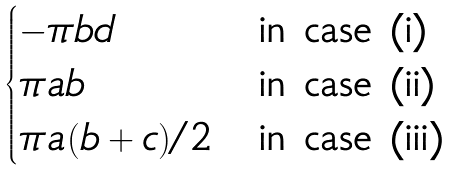<formula> <loc_0><loc_0><loc_500><loc_500>\begin{cases} - \pi b d & \text {in case (i)} \\ \pi a b & \text {in case (ii)} \\ \pi a ( b + c ) / 2 & \text {in case (iii)} \end{cases}</formula> 